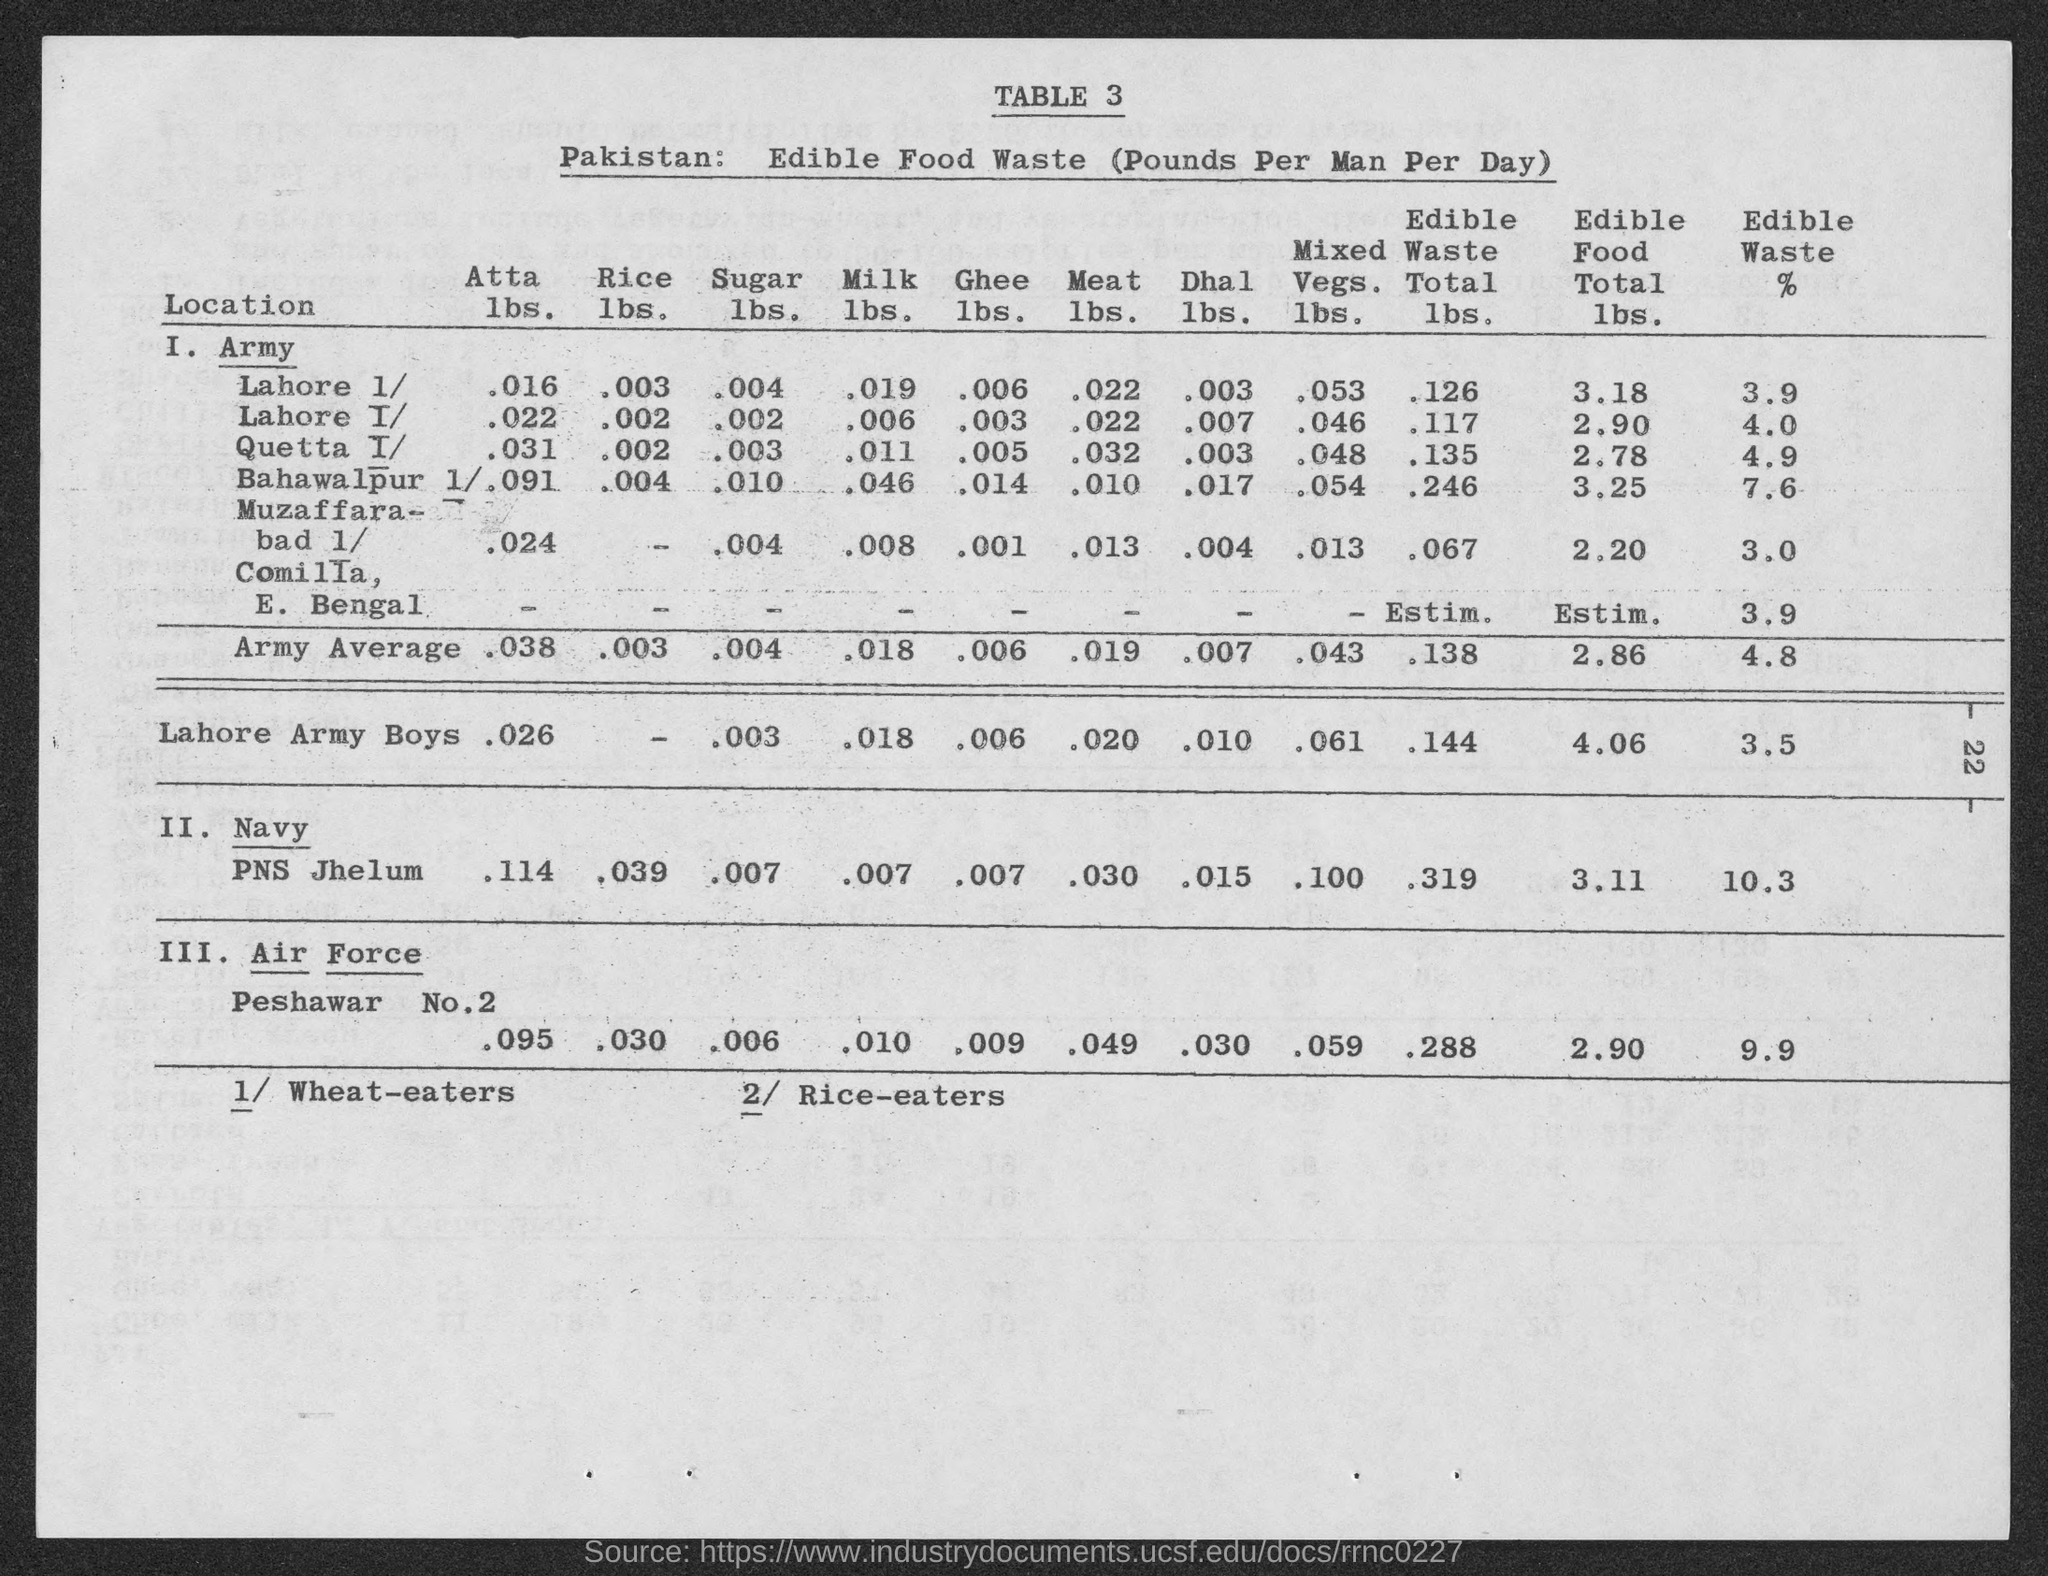Draw attention to some important aspects in this diagram. The unit of edible food waste is measured in pounds per man per day. The table titled "Pakistan" contains information on edible food waste in pounds per man per day. 